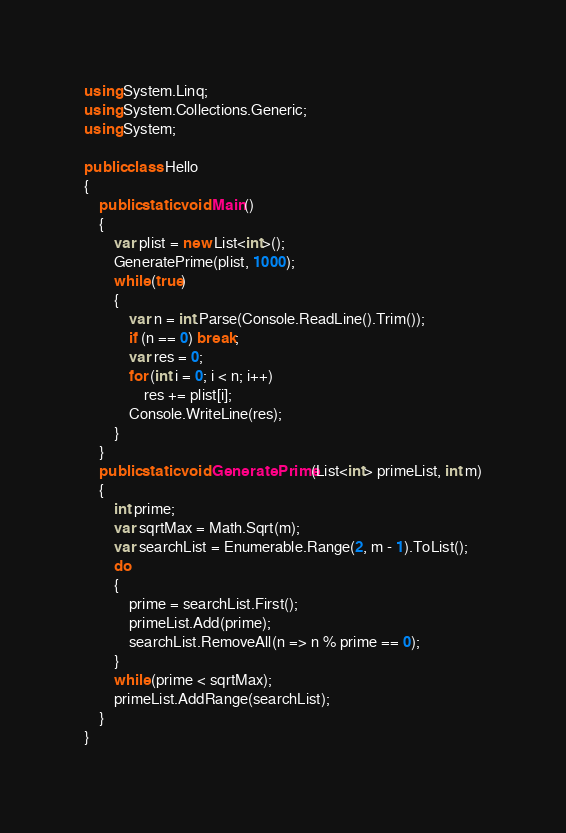<code> <loc_0><loc_0><loc_500><loc_500><_C#_>using System.Linq;
using System.Collections.Generic;
using System;

public class Hello
{
    public static void Main()
    {
        var plist = new List<int>();
        GeneratePrime(plist, 1000);
        while (true)
        {
            var n = int.Parse(Console.ReadLine().Trim());
            if (n == 0) break;
            var res = 0;
            for (int i = 0; i < n; i++)
                res += plist[i];
            Console.WriteLine(res);
        }
    }
    public static void GeneratePrime(List<int> primeList, int m)
    {
        int prime;
        var sqrtMax = Math.Sqrt(m);
        var searchList = Enumerable.Range(2, m - 1).ToList();
        do
        {
            prime = searchList.First();
            primeList.Add(prime);
            searchList.RemoveAll(n => n % prime == 0);
        }
        while (prime < sqrtMax);
        primeList.AddRange(searchList);
    }
}</code> 